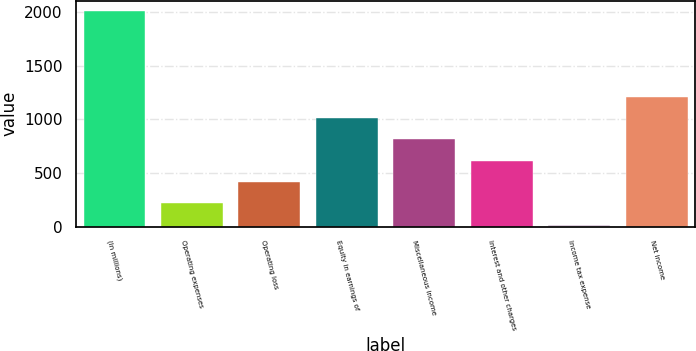Convert chart. <chart><loc_0><loc_0><loc_500><loc_500><bar_chart><fcel>(In millions)<fcel>Operating expenses<fcel>Operating loss<fcel>Equity in earnings of<fcel>Miscellaneous income<fcel>Interest and other charges<fcel>Income tax expense<fcel>Net income<nl><fcel>2007<fcel>216<fcel>415<fcel>1012<fcel>813<fcel>614<fcel>17<fcel>1211<nl></chart> 